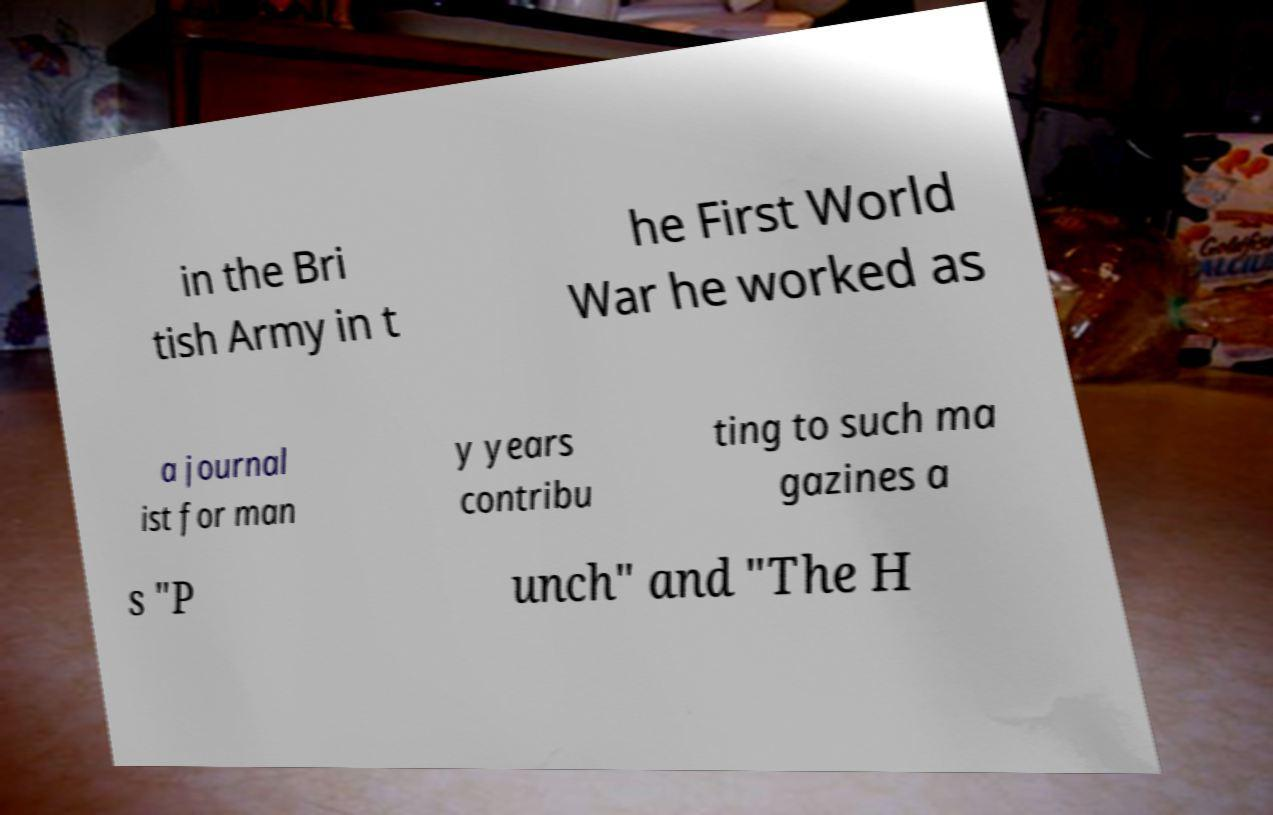There's text embedded in this image that I need extracted. Can you transcribe it verbatim? in the Bri tish Army in t he First World War he worked as a journal ist for man y years contribu ting to such ma gazines a s "P unch" and "The H 